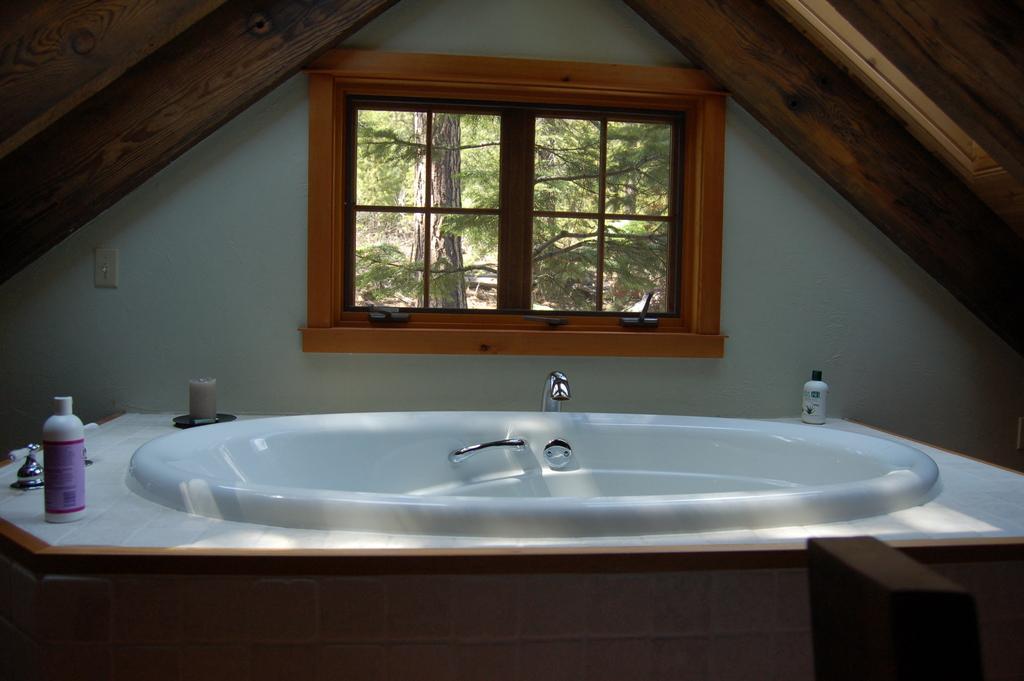Could you give a brief overview of what you see in this image? There is a sink present at the bottom of this image. We can see a window in the middle of this image. We can see trees through this window. 